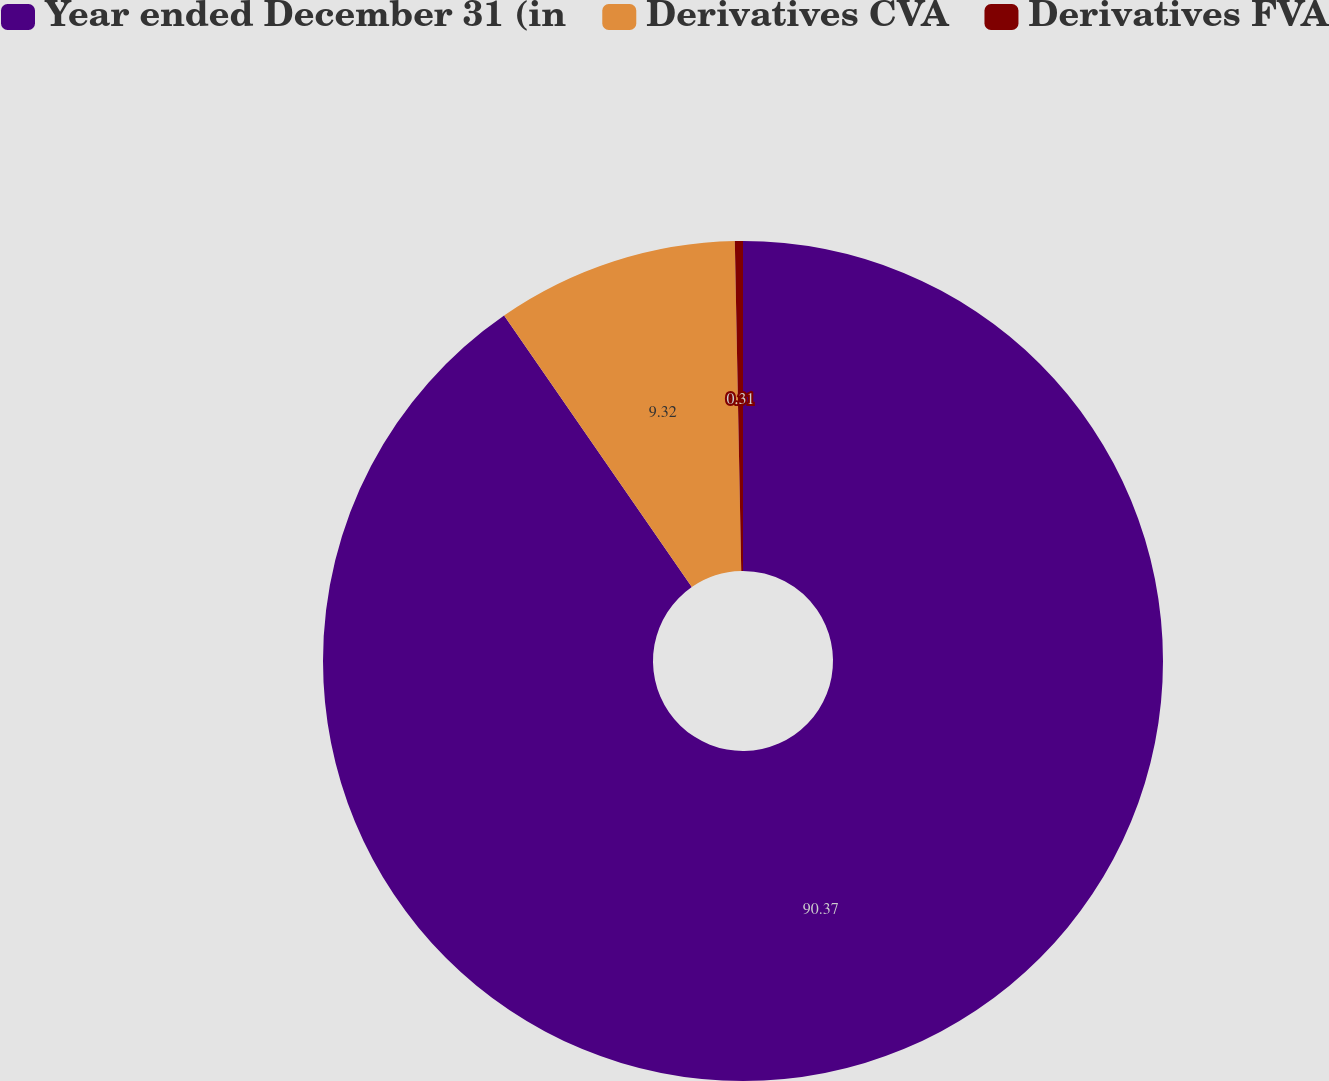Convert chart. <chart><loc_0><loc_0><loc_500><loc_500><pie_chart><fcel>Year ended December 31 (in<fcel>Derivatives CVA<fcel>Derivatives FVA<nl><fcel>90.37%<fcel>9.32%<fcel>0.31%<nl></chart> 